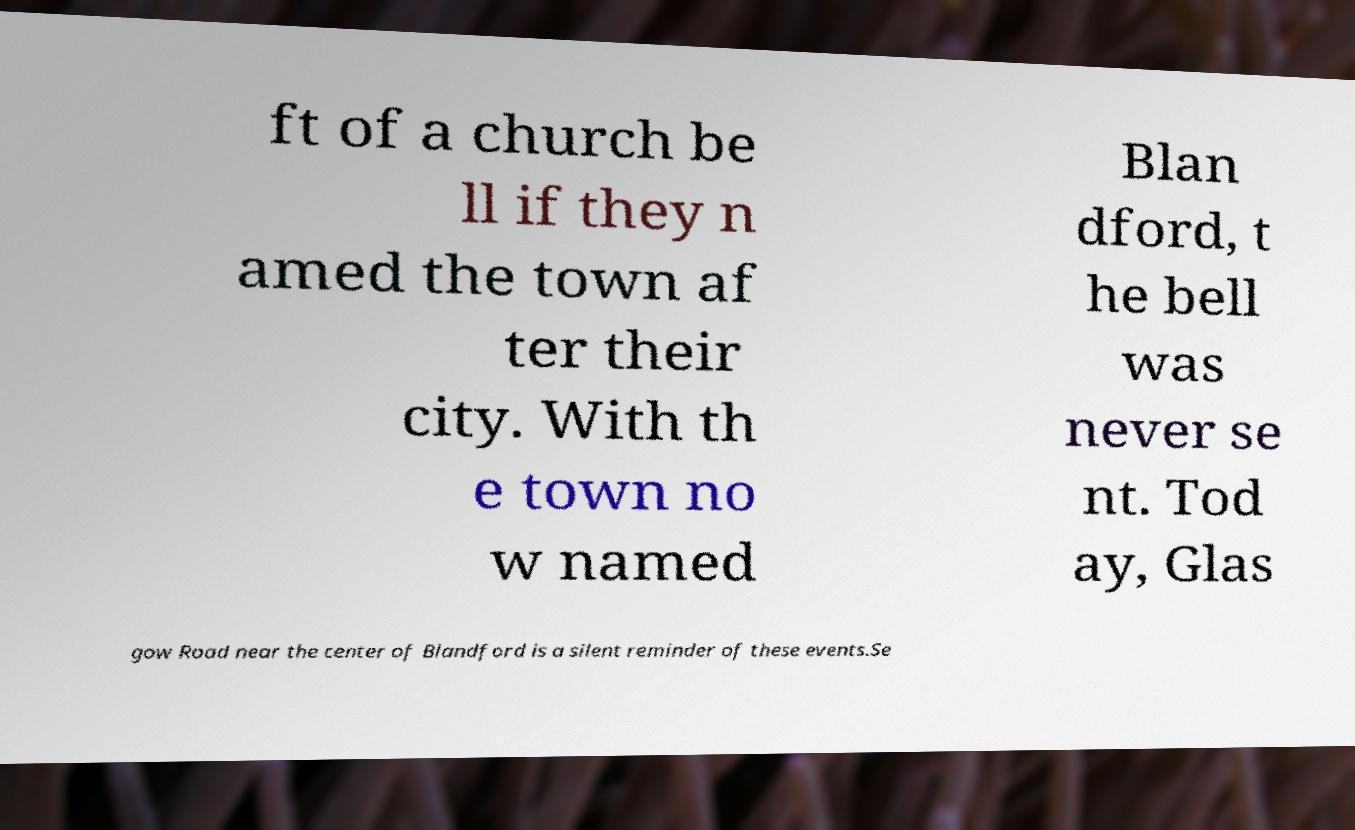What messages or text are displayed in this image? I need them in a readable, typed format. ft of a church be ll if they n amed the town af ter their city. With th e town no w named Blan dford, t he bell was never se nt. Tod ay, Glas gow Road near the center of Blandford is a silent reminder of these events.Se 